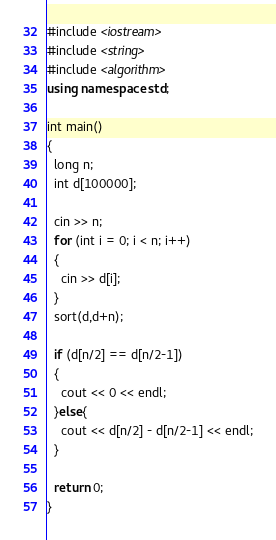<code> <loc_0><loc_0><loc_500><loc_500><_C++_>#include <iostream>
#include <string>
#include <algorithm>
using namespace std;

int main()
{
  long n;
  int d[100000];

  cin >> n;
  for (int i = 0; i < n; i++)
  {
    cin >> d[i];
  }
  sort(d,d+n);

  if (d[n/2] == d[n/2-1])
  {
    cout << 0 << endl;
  }else{
    cout << d[n/2] - d[n/2-1] << endl;
  }

  return 0;
}</code> 